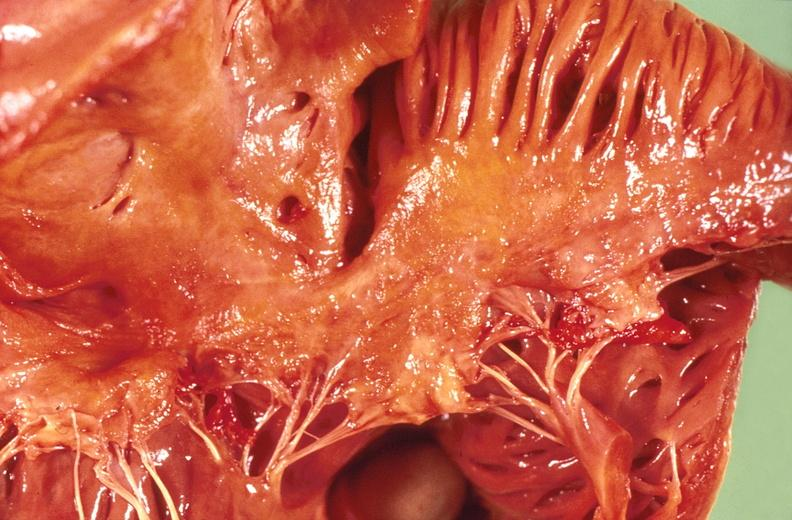does newborn cord around neck show amyloidosis?
Answer the question using a single word or phrase. No 